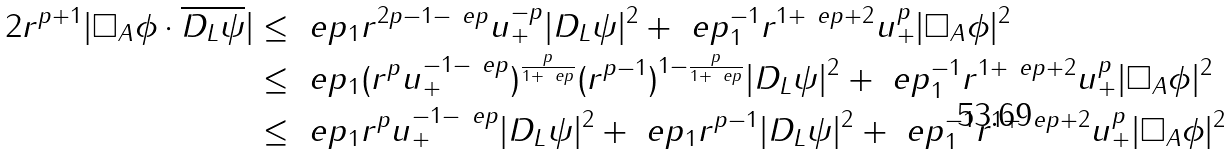<formula> <loc_0><loc_0><loc_500><loc_500>2 r ^ { p + 1 } | \Box _ { A } \phi \cdot \overline { D _ { L } \psi } | & \leq \ e p _ { 1 } r ^ { 2 p - 1 - \ e p } u _ { + } ^ { - p } | D _ { L } \psi | ^ { 2 } + \ e p _ { 1 } ^ { - 1 } r ^ { 1 + \ e p + 2 } u _ { + } ^ { p } | \Box _ { A } \phi | ^ { 2 } \\ & \leq \ e p _ { 1 } ( r ^ { p } u _ { + } ^ { - 1 - \ e p } ) ^ { \frac { p } { 1 + \ e p } } ( r ^ { p - 1 } ) ^ { 1 - \frac { p } { 1 + \ e p } } | D _ { L } \psi | ^ { 2 } + \ e p _ { 1 } ^ { - 1 } r ^ { 1 + \ e p + 2 } u _ { + } ^ { p } | \Box _ { A } \phi | ^ { 2 } \\ & \leq \ e p _ { 1 } r ^ { p } u _ { + } ^ { - 1 - \ e p } | D _ { L } \psi | ^ { 2 } + \ e p _ { 1 } r ^ { p - 1 } | D _ { L } \psi | ^ { 2 } + \ e p _ { 1 } ^ { - 1 } r ^ { 1 + \ e p + 2 } u _ { + } ^ { p } | \Box _ { A } \phi | ^ { 2 }</formula> 